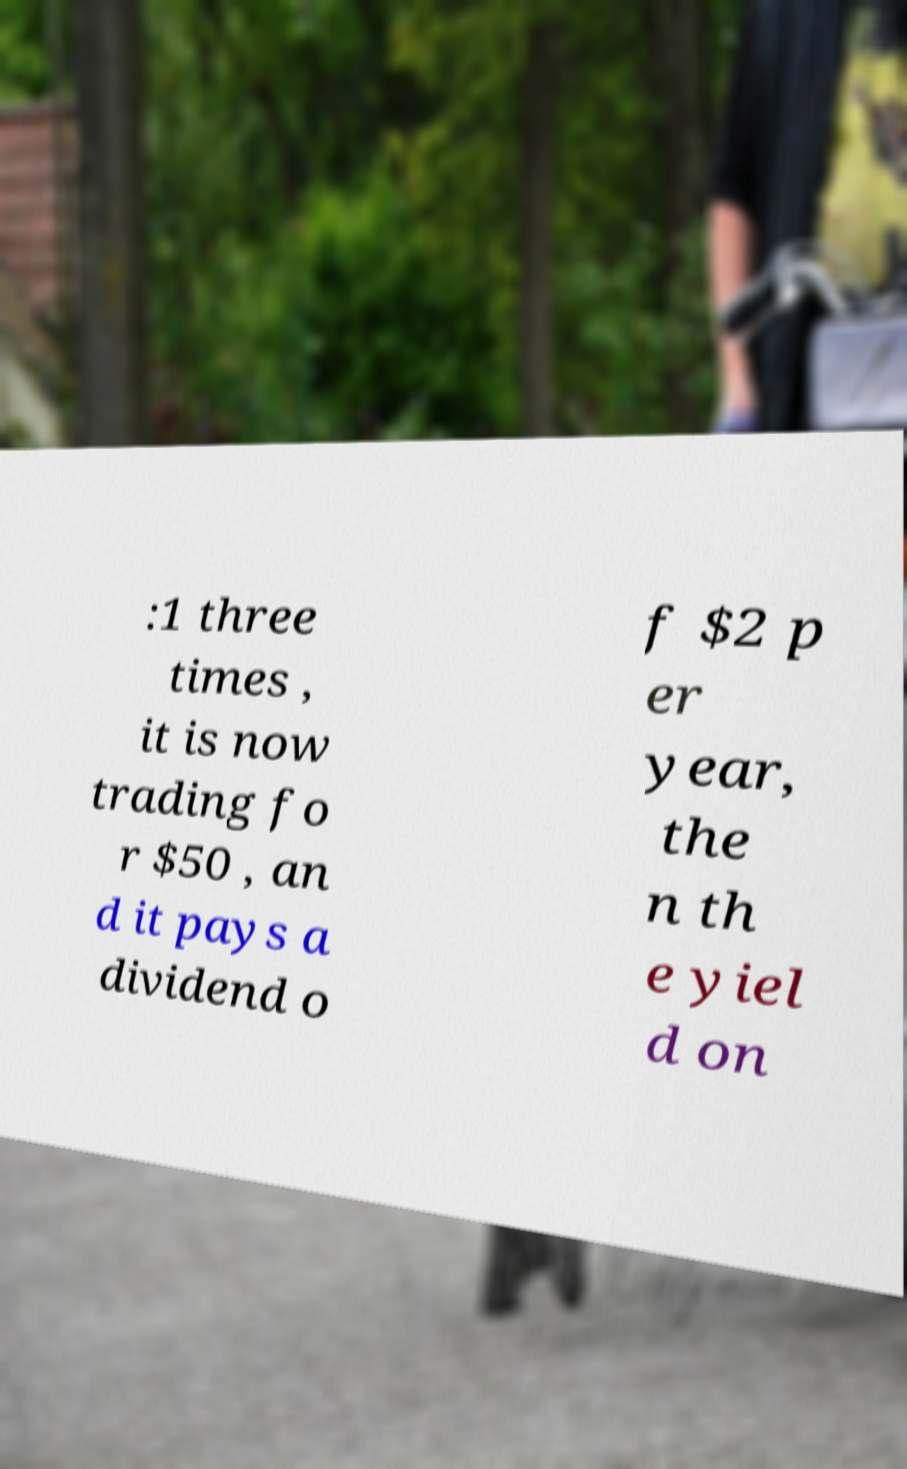Please identify and transcribe the text found in this image. :1 three times , it is now trading fo r $50 , an d it pays a dividend o f $2 p er year, the n th e yiel d on 